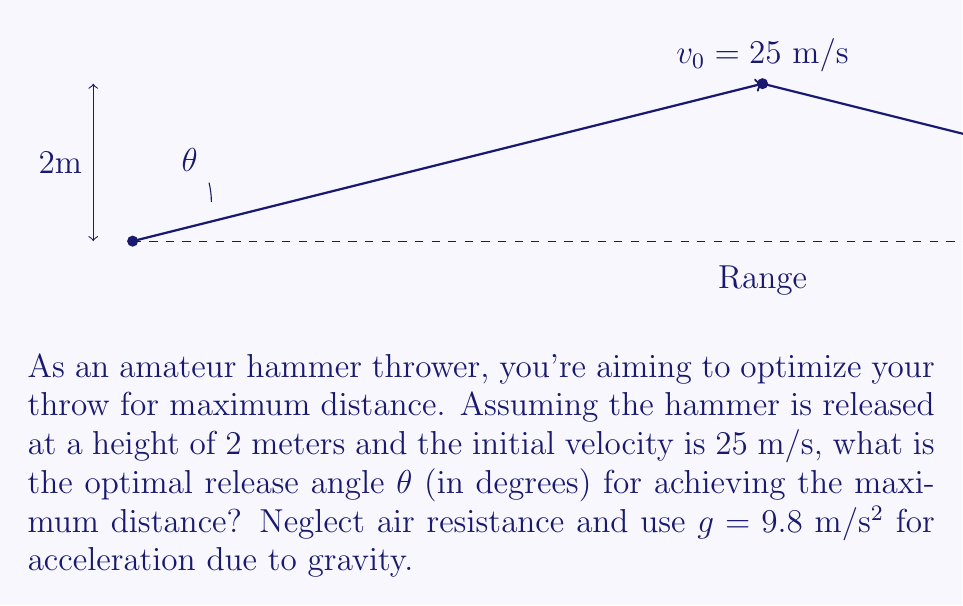What is the answer to this math problem? To find the optimal angle for maximum distance in hammer throw, we'll use the equation for the range of a projectile and maximize it.

1) The range equation for a projectile launched from height h is:

   $$R = \frac{v_0 \cos θ}{g} \left(v_0 \sin θ + \sqrt{(v_0 \sin θ)^2 + 2gh}\right)$$

2) We're given:
   $v_0 = 25$ m/s
   $h = 2$ m
   $g = 9.8$ m/s²

3) To find the maximum range, we need to differentiate R with respect to θ and set it to zero:

   $$\frac{dR}{dθ} = 0$$

4) This leads to a complex equation. However, there's a simpler way to approach this problem.

5) For a projectile launched from ground level (h = 0), the optimal angle is always 45°. When launched from a height, the optimal angle is slightly less than 45°.

6) We can use the approximation:

   $$θ_{optimal} ≈ 45° - \frac{1}{2} \tan^{-1}\left(\frac{3gh}{v_0^2}\right)$$

7) Plugging in our values:

   $$θ_{optimal} ≈ 45° - \frac{1}{2} \tan^{-1}\left(\frac{3 * 9.8 * 2}{25^2}\right)$$

8) Calculating:
   $$θ_{optimal} ≈ 45° - \frac{1}{2} \tan^{-1}(0.0941)$$
   $$θ_{optimal} ≈ 45° - 1.35°$$
   $$θ_{optimal} ≈ 43.65°$$

Therefore, the optimal angle for maximum distance in this hammer throw scenario is approximately 43.65°.
Answer: $43.65°$ 